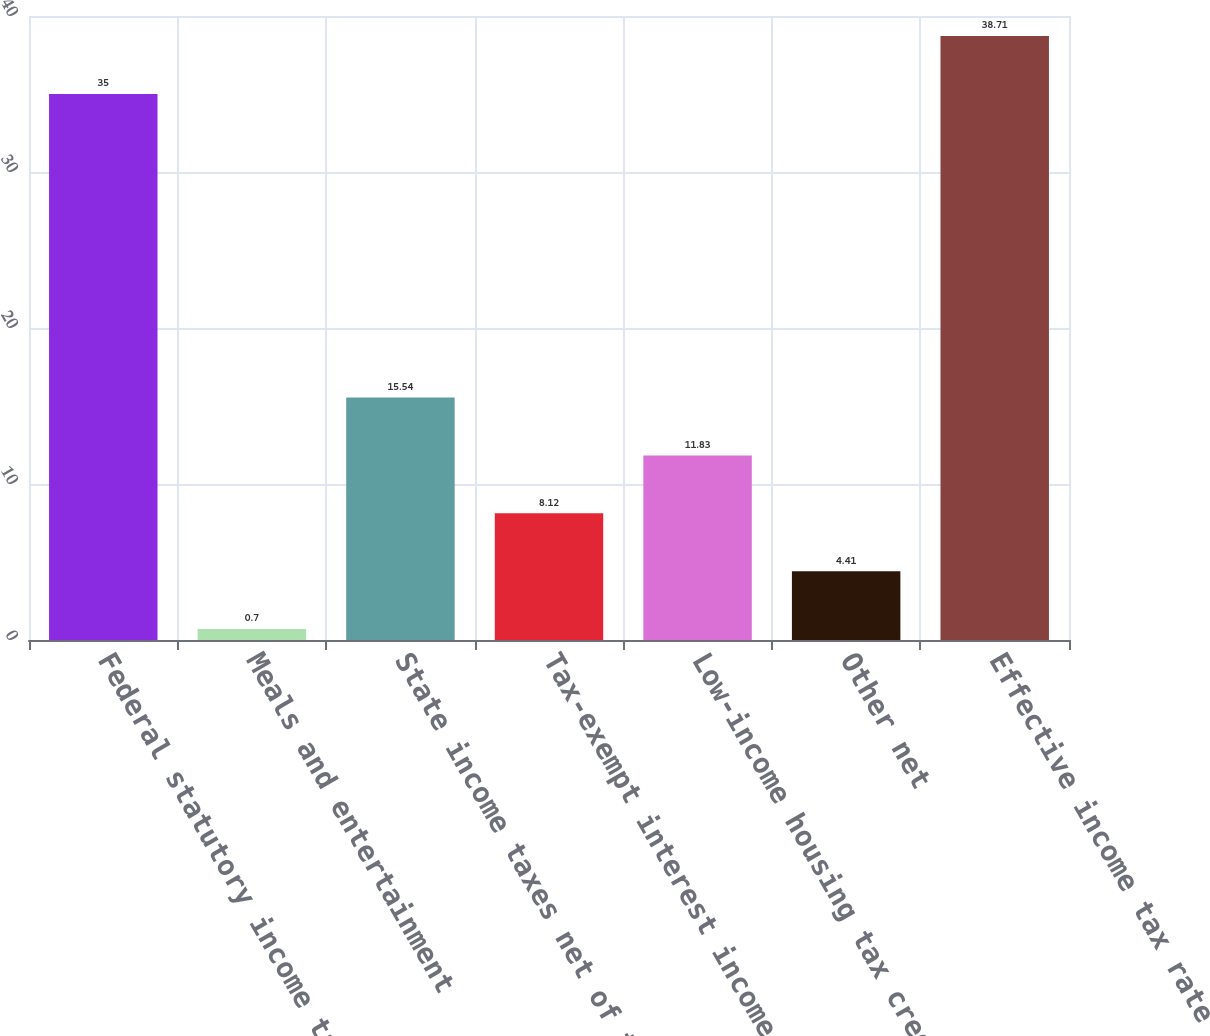Convert chart to OTSL. <chart><loc_0><loc_0><loc_500><loc_500><bar_chart><fcel>Federal statutory income tax<fcel>Meals and entertainment<fcel>State income taxes net of the<fcel>Tax-exempt interest income<fcel>Low-income housing tax credit<fcel>Other net<fcel>Effective income tax rate<nl><fcel>35<fcel>0.7<fcel>15.54<fcel>8.12<fcel>11.83<fcel>4.41<fcel>38.71<nl></chart> 